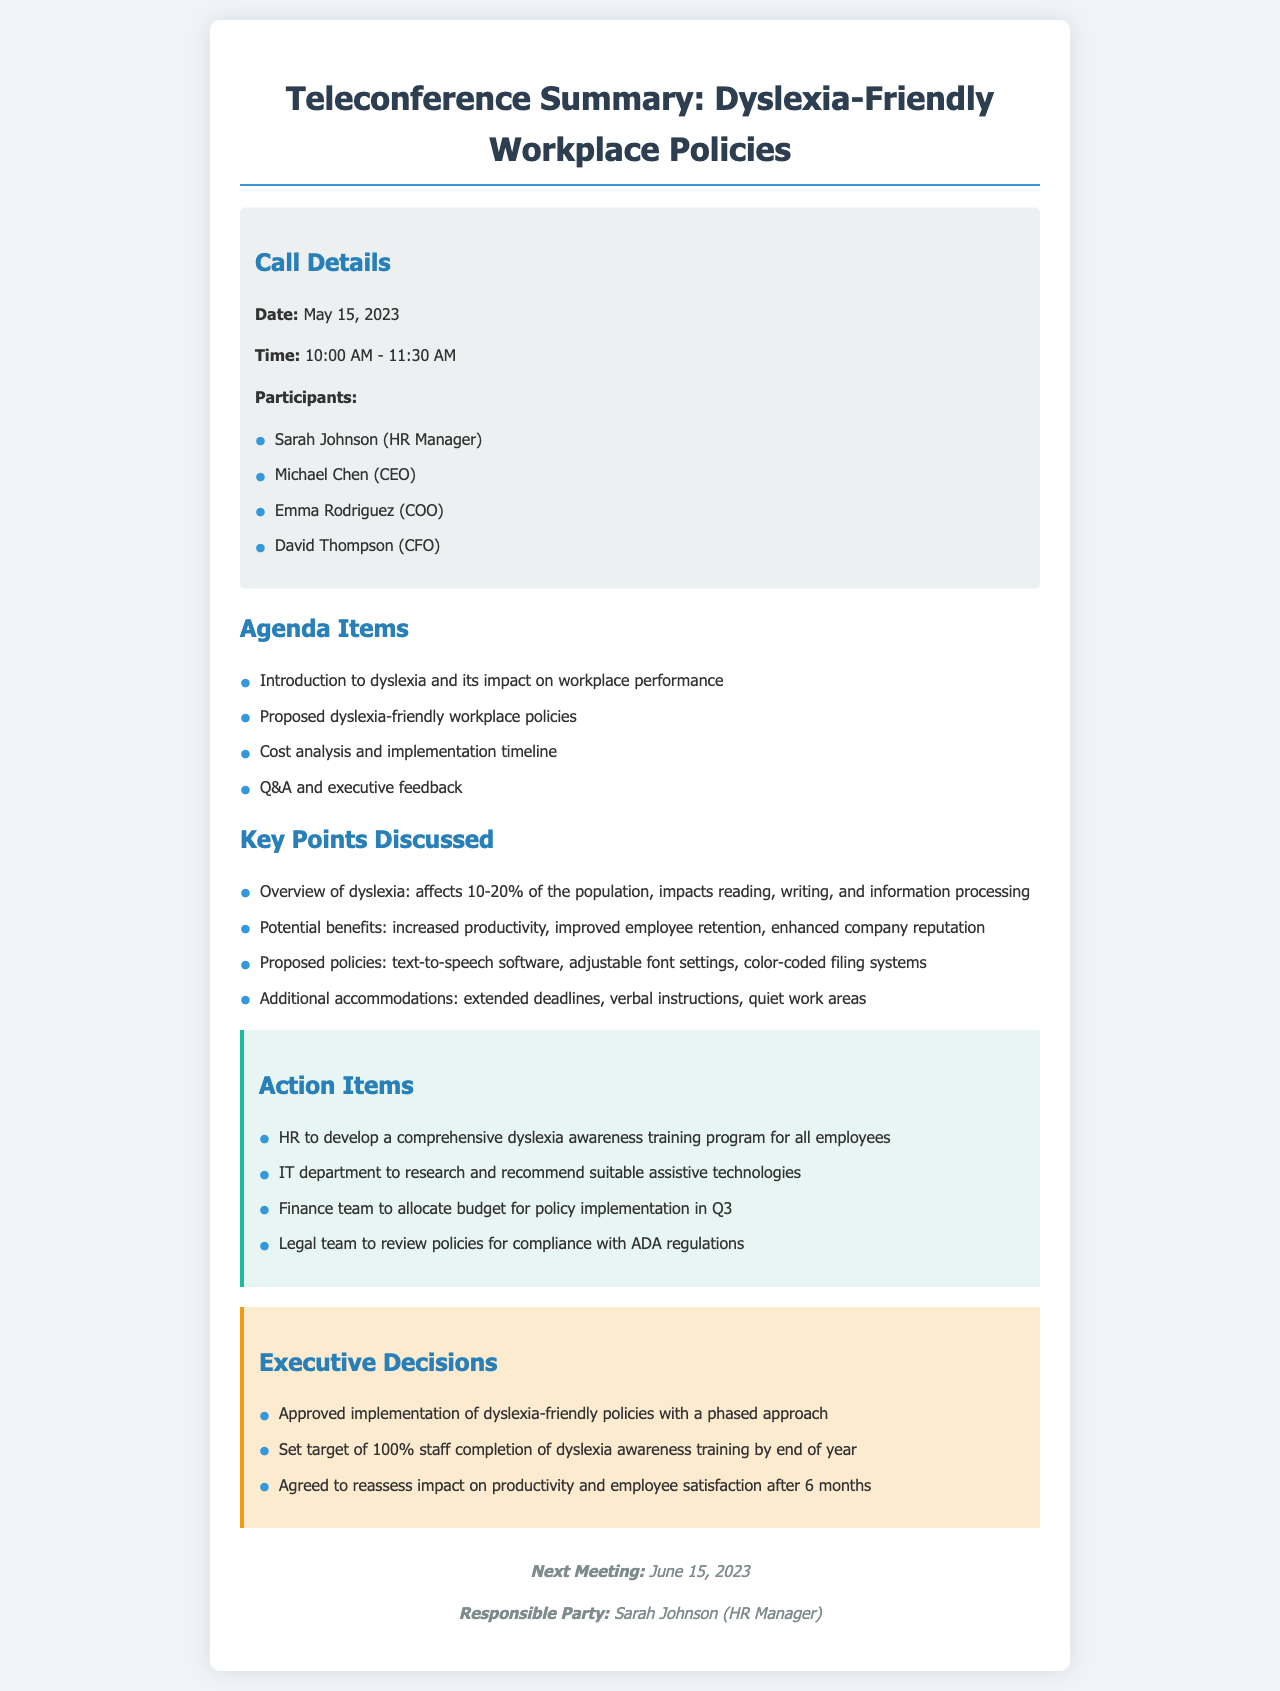What date was the teleconference held? The date is listed under the call details section of the document.
Answer: May 15, 2023 Who is the HR Manager that participated in the call? This information is found in the list of participants in the call details.
Answer: Sarah Johnson What is one proposed dyslexia-friendly policy mentioned? The proposed policies can be found in the key points discussed section.
Answer: Text-to-speech software How many items are listed in the action items section? This can be counted in the action items section of the document.
Answer: Four What is the target completion percentage for dyslexia awareness training? This detail is stated under the executive decisions section.
Answer: 100% What impact on productivity is the company planning to reassess? This context is derived from the executive decisions on assessing policies.
Answer: After 6 months Who is responsible for developing the dyslexia awareness training program? This responsibility is outlined in the action items section.
Answer: HR What time did the teleconference start? This information is noted in the call details section.
Answer: 10:00 AM 